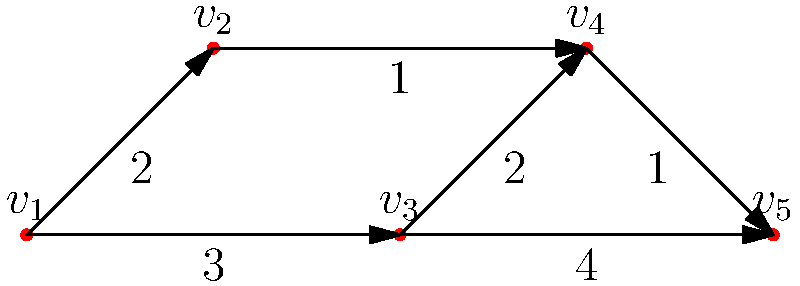In a multi-sport tournament scheduling problem, similar to organizing a local sports event that could be featured on Good Day NWA, the directed graph above represents the order and duration of events. Each vertex represents an event, and each edge represents the time constraint between events. The weight on each edge indicates the minimum time (in hours) that must pass between the end of one event and the start of the next. What is the minimum total time required to complete all events, assuming each event takes 1 hour? To solve this problem, we need to find the longest path in the directed acyclic graph (DAG), also known as the critical path. Here's how we can approach it:

1. First, we need to identify all possible paths from the start (v1) to the end (v5):
   - Path 1: v1 -> v2 -> v4 -> v5
   - Path 2: v1 -> v2 -> v3 -> v5
   - Path 3: v1 -> v3 -> v4 -> v5
   - Path 4: v1 -> v3 -> v5

2. Now, let's calculate the total time for each path:
   - Path 1: 2 + 1 + 3 + 1 + 4 + 1 = 12 hours
   - Path 2: 2 + 1 + 1 + 1 + 1 + 1 = 7 hours
   - Path 3: 3 + 1 + 2 + 1 + 1 + 1 = 9 hours
   - Path 4: 3 + 1 + 4 + 1 = 9 hours

3. The longest path is Path 1, which takes 12 hours.

4. This longest path represents the critical path, which determines the minimum total time required to complete all events.

5. Therefore, the minimum total time to complete all events is 12 hours.
Answer: 12 hours 